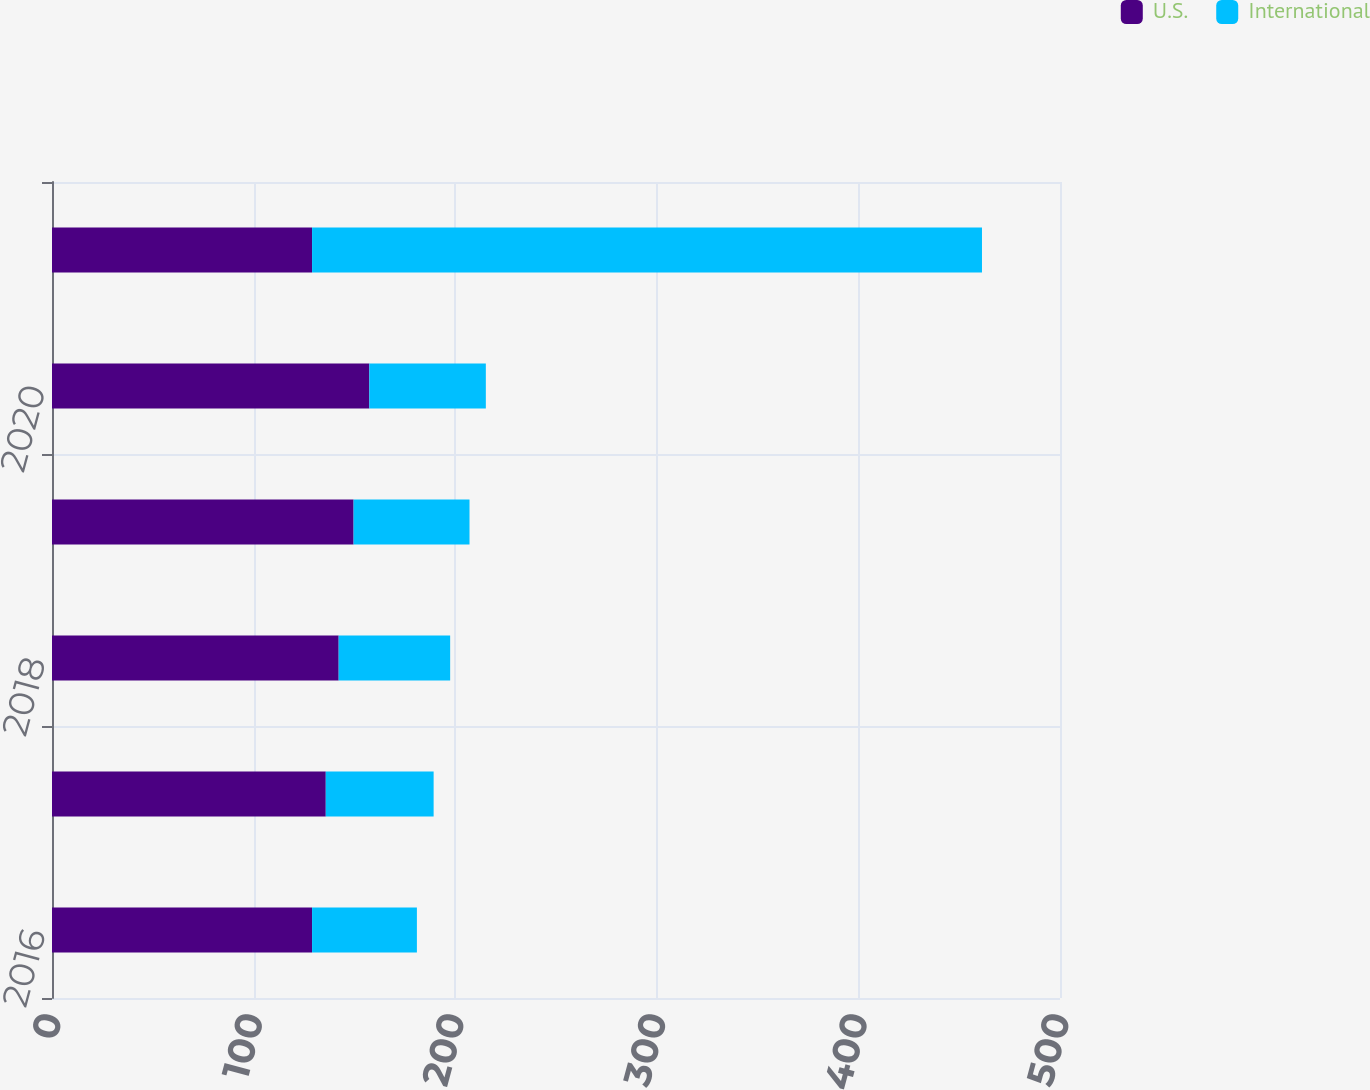Convert chart. <chart><loc_0><loc_0><loc_500><loc_500><stacked_bar_chart><ecel><fcel>2016<fcel>2017<fcel>2018<fcel>2019<fcel>2020<fcel>2021-2025<nl><fcel>U.S.<fcel>129<fcel>135.8<fcel>142.2<fcel>149.6<fcel>157.4<fcel>129<nl><fcel>International<fcel>52<fcel>53.5<fcel>55.3<fcel>57.5<fcel>57.8<fcel>332.3<nl></chart> 